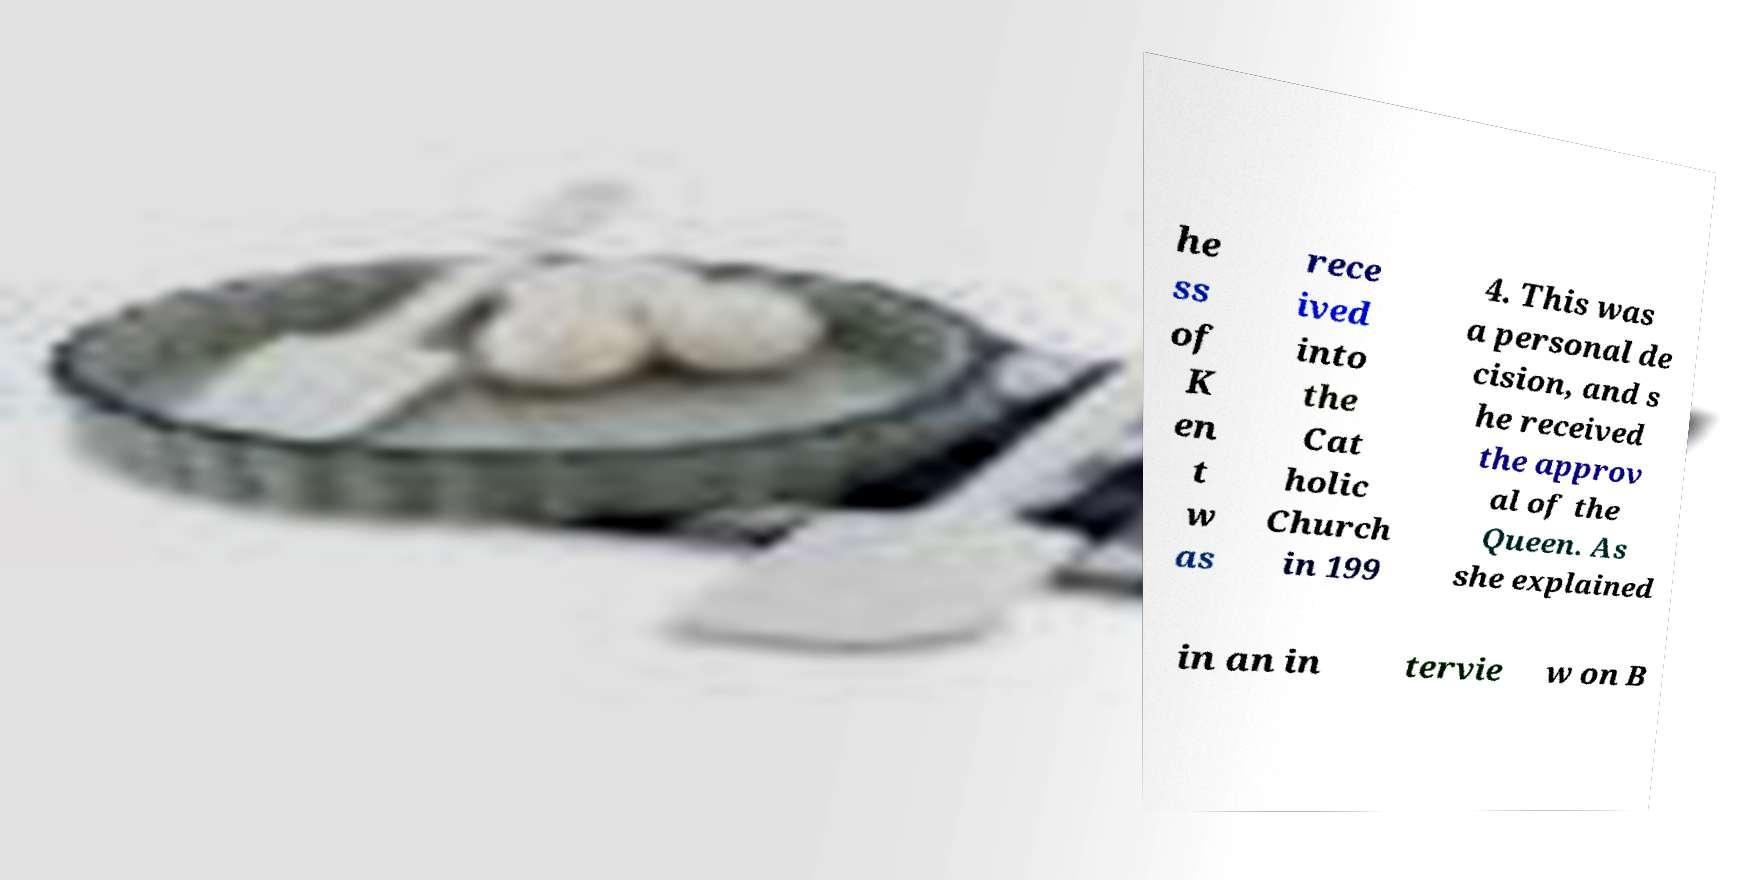Can you accurately transcribe the text from the provided image for me? he ss of K en t w as rece ived into the Cat holic Church in 199 4. This was a personal de cision, and s he received the approv al of the Queen. As she explained in an in tervie w on B 